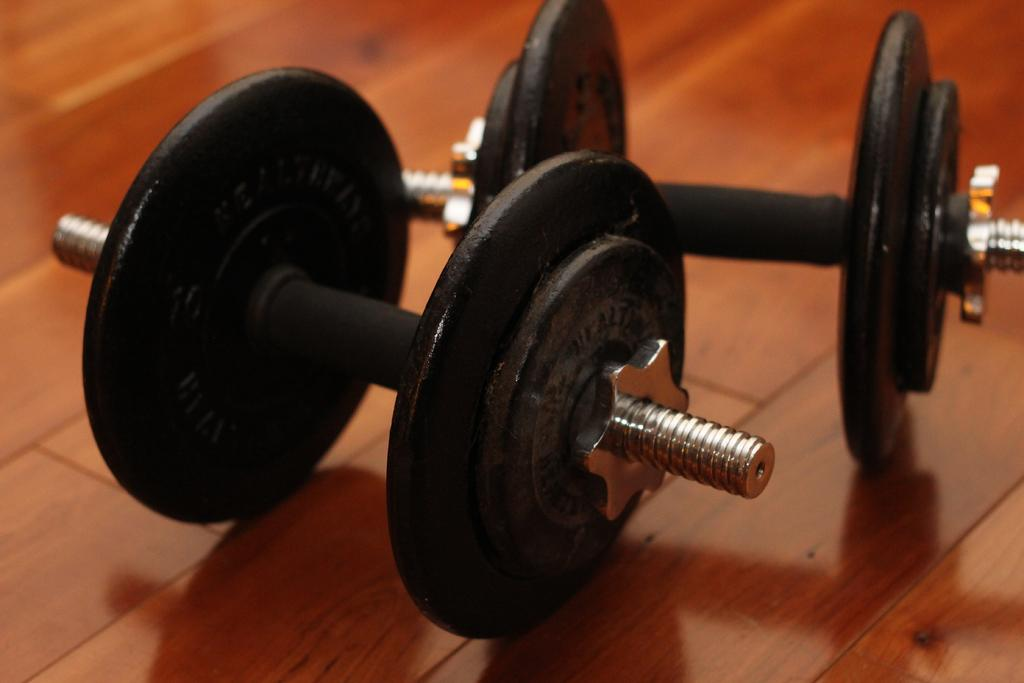What type of exercise equipment is in the image? There is a pair of dumbbells in the image. Where are the dumbbells located? The dumbbells are on the floor. What type of account is being discussed in the image? There is no account being discussed in the image; it features a pair of dumbbells on the floor. What type of wine is being served in the image? There is no wine or glass present in the image. 